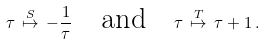<formula> <loc_0><loc_0><loc_500><loc_500>\tau \, \stackrel { S } { \mapsto } \, - \frac { 1 } { \tau } \quad \text {and} \quad \tau \, \stackrel { T } { \mapsto } \, \tau + 1 \, .</formula> 